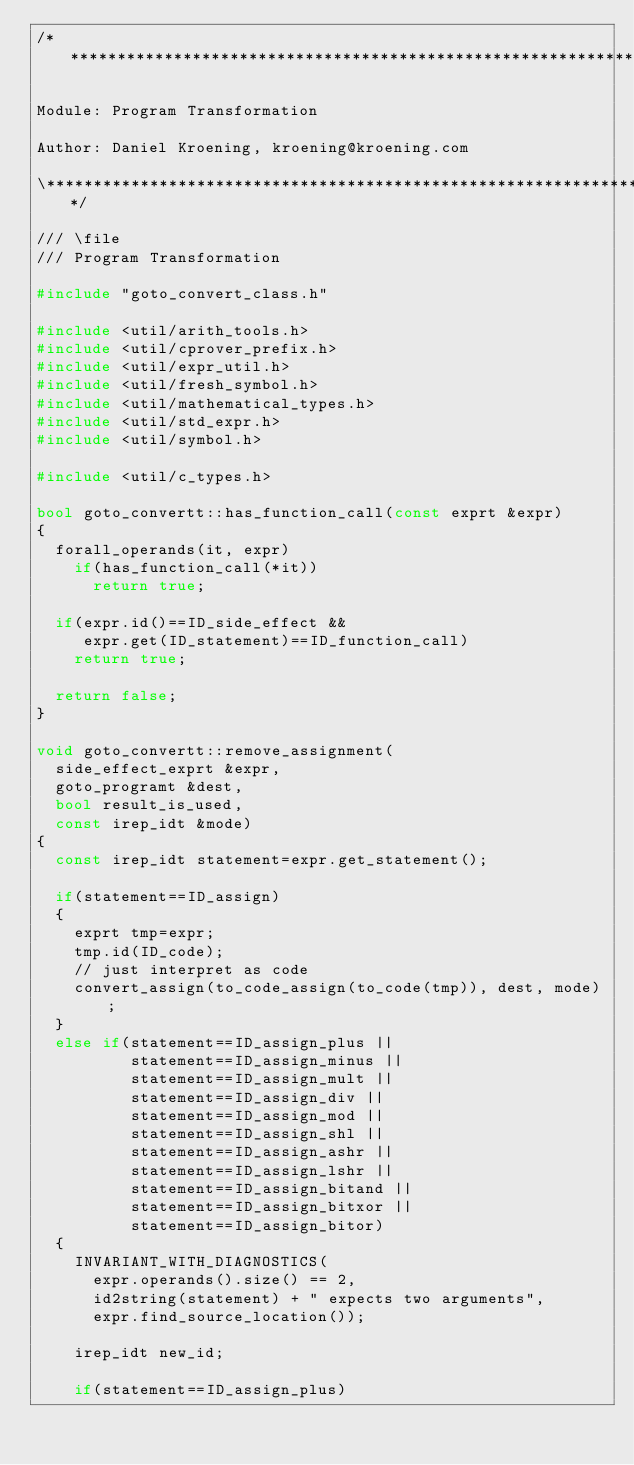Convert code to text. <code><loc_0><loc_0><loc_500><loc_500><_C++_>/*******************************************************************\

Module: Program Transformation

Author: Daniel Kroening, kroening@kroening.com

\*******************************************************************/

/// \file
/// Program Transformation

#include "goto_convert_class.h"

#include <util/arith_tools.h>
#include <util/cprover_prefix.h>
#include <util/expr_util.h>
#include <util/fresh_symbol.h>
#include <util/mathematical_types.h>
#include <util/std_expr.h>
#include <util/symbol.h>

#include <util/c_types.h>

bool goto_convertt::has_function_call(const exprt &expr)
{
  forall_operands(it, expr)
    if(has_function_call(*it))
      return true;

  if(expr.id()==ID_side_effect &&
     expr.get(ID_statement)==ID_function_call)
    return true;

  return false;
}

void goto_convertt::remove_assignment(
  side_effect_exprt &expr,
  goto_programt &dest,
  bool result_is_used,
  const irep_idt &mode)
{
  const irep_idt statement=expr.get_statement();

  if(statement==ID_assign)
  {
    exprt tmp=expr;
    tmp.id(ID_code);
    // just interpret as code
    convert_assign(to_code_assign(to_code(tmp)), dest, mode);
  }
  else if(statement==ID_assign_plus ||
          statement==ID_assign_minus ||
          statement==ID_assign_mult ||
          statement==ID_assign_div ||
          statement==ID_assign_mod ||
          statement==ID_assign_shl ||
          statement==ID_assign_ashr ||
          statement==ID_assign_lshr ||
          statement==ID_assign_bitand ||
          statement==ID_assign_bitxor ||
          statement==ID_assign_bitor)
  {
    INVARIANT_WITH_DIAGNOSTICS(
      expr.operands().size() == 2,
      id2string(statement) + " expects two arguments",
      expr.find_source_location());

    irep_idt new_id;

    if(statement==ID_assign_plus)</code> 